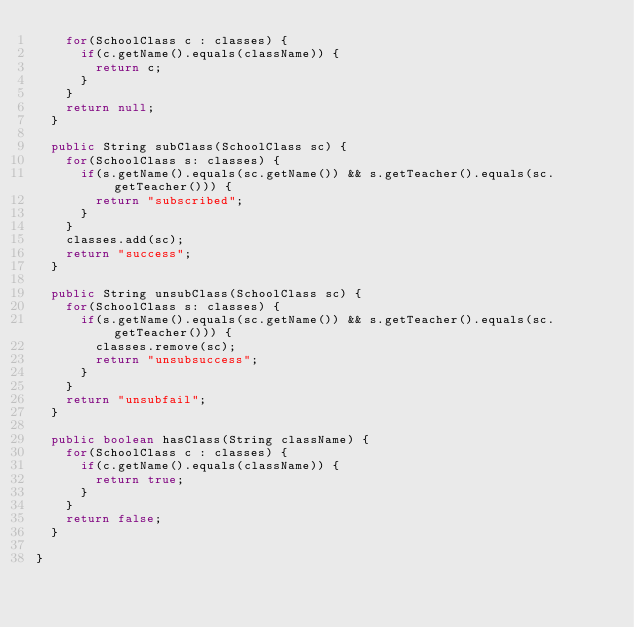<code> <loc_0><loc_0><loc_500><loc_500><_Java_>		for(SchoolClass c : classes) {
			if(c.getName().equals(className)) {
				return c;
			}
		}
		return null;
	}
	
	public String subClass(SchoolClass sc) {
		for(SchoolClass s: classes) {
			if(s.getName().equals(sc.getName()) && s.getTeacher().equals(sc.getTeacher())) {
				return "subscribed";
			}
		}
		classes.add(sc);
		return "success";
	}
	
	public String unsubClass(SchoolClass sc) {
		for(SchoolClass s: classes) {
			if(s.getName().equals(sc.getName()) && s.getTeacher().equals(sc.getTeacher())) {
				classes.remove(sc);
				return "unsubsuccess";
			}
		}
		return "unsubfail";
	}
	
	public boolean hasClass(String className) {
		for(SchoolClass c : classes) {
			if(c.getName().equals(className)) {
				return true;
			}
		}
		return false;
	}

}
</code> 